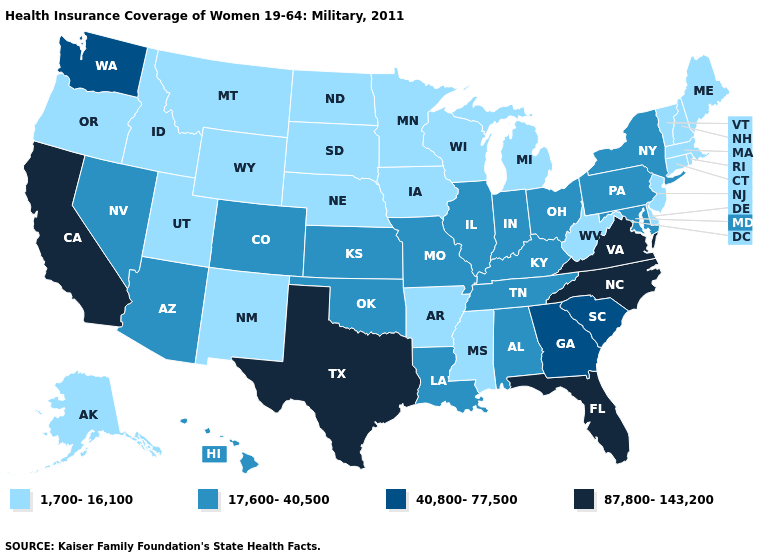How many symbols are there in the legend?
Give a very brief answer. 4. What is the lowest value in states that border New Hampshire?
Quick response, please. 1,700-16,100. What is the value of Georgia?
Keep it brief. 40,800-77,500. Which states have the highest value in the USA?
Give a very brief answer. California, Florida, North Carolina, Texas, Virginia. Does the map have missing data?
Keep it brief. No. Name the states that have a value in the range 40,800-77,500?
Be succinct. Georgia, South Carolina, Washington. How many symbols are there in the legend?
Write a very short answer. 4. Does the map have missing data?
Keep it brief. No. What is the value of Wisconsin?
Short answer required. 1,700-16,100. Does California have the highest value in the West?
Answer briefly. Yes. Among the states that border West Virginia , which have the lowest value?
Keep it brief. Kentucky, Maryland, Ohio, Pennsylvania. What is the value of Pennsylvania?
Answer briefly. 17,600-40,500. What is the lowest value in states that border New Mexico?
Short answer required. 1,700-16,100. Among the states that border Colorado , does Kansas have the lowest value?
Give a very brief answer. No. Does Rhode Island have the lowest value in the Northeast?
Answer briefly. Yes. 